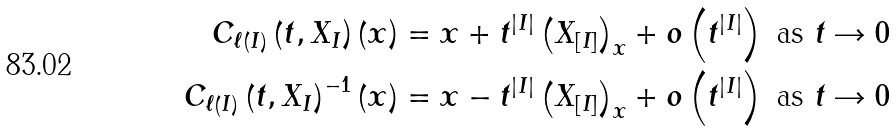<formula> <loc_0><loc_0><loc_500><loc_500>C _ { \ell \left ( I \right ) } \left ( t , X _ { I } \right ) \left ( x \right ) & = x + t ^ { \left | I \right | } \left ( X _ { \left [ I \right ] } \right ) _ { x } + o \left ( t ^ { \left | I \right | } \right ) \text { as } t \rightarrow 0 \\ C _ { \ell \left ( I \right ) } \left ( t , X _ { I } \right ) ^ { - 1 } \left ( x \right ) & = x - t ^ { \left | I \right | } \left ( X _ { \left [ I \right ] } \right ) _ { x } + o \left ( t ^ { \left | I \right | } \right ) \text { as } t \rightarrow 0</formula> 